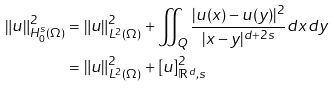<formula> <loc_0><loc_0><loc_500><loc_500>\left \| u \right \| _ { H _ { 0 } ^ { s } ( \Omega ) } ^ { 2 } & = \left \| u \right \| _ { L ^ { 2 } ( \Omega ) } ^ { 2 } + \iint _ { Q } \frac { | u ( x ) - u ( y ) | ^ { 2 } } { | x - y | ^ { d + 2 s } } d x d y \\ & = \left \| u \right \| _ { L ^ { 2 } ( \Omega ) } ^ { 2 } + [ u ] _ { \mathbb { R } ^ { d } , s } ^ { 2 }</formula> 